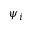Convert formula to latex. <formula><loc_0><loc_0><loc_500><loc_500>\psi _ { i }</formula> 